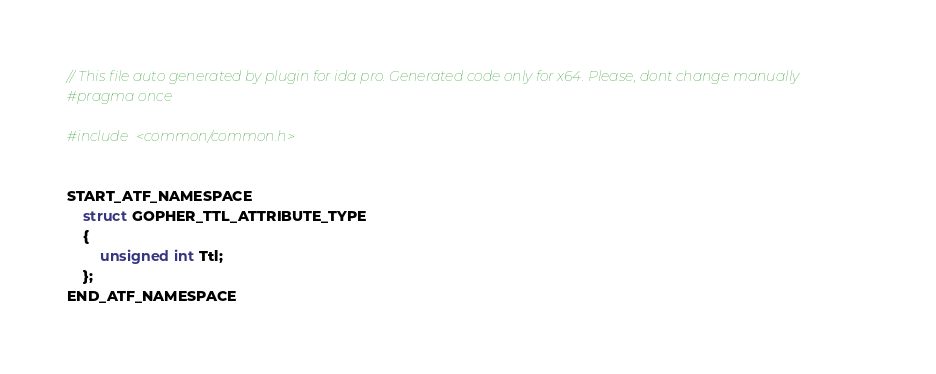Convert code to text. <code><loc_0><loc_0><loc_500><loc_500><_C++_>// This file auto generated by plugin for ida pro. Generated code only for x64. Please, dont change manually
#pragma once

#include <common/common.h>


START_ATF_NAMESPACE
    struct GOPHER_TTL_ATTRIBUTE_TYPE
    {
        unsigned int Ttl;
    };
END_ATF_NAMESPACE
</code> 